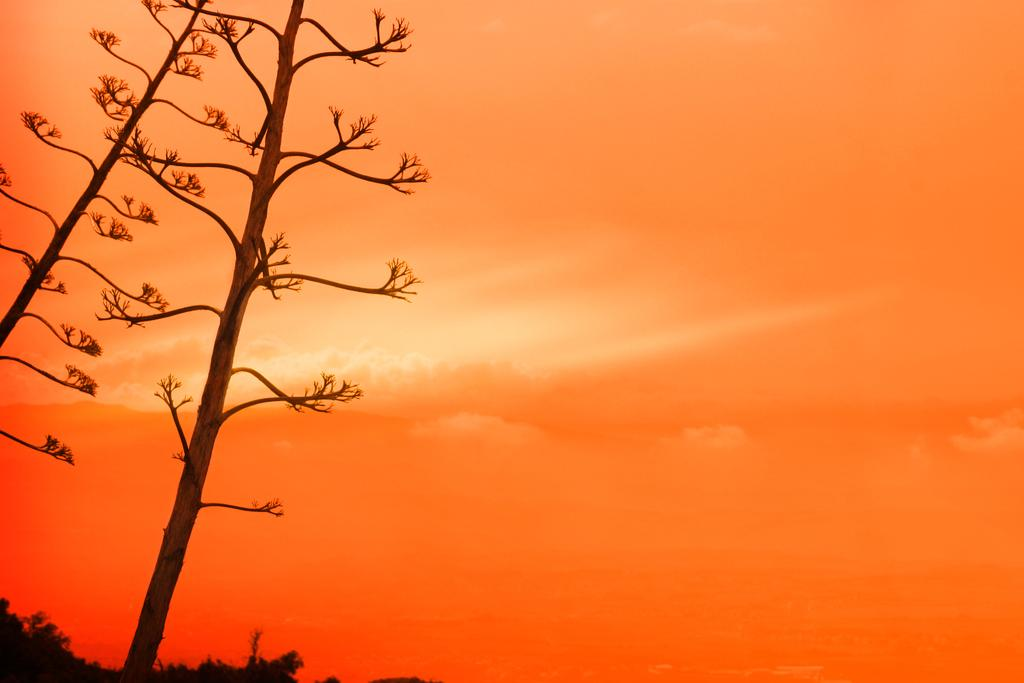What type of vegetation is on the left side of the image? There are trees on the left side of the image. What can be seen in the middle of the image? There are clouds in the middle of the image. What else is visible in the middle of the image besides the clouds? The sky is also visible in the middle of the image. What type of toy is being used at the party in the image? There is no toy or party present in the image; it features trees, clouds, and the sky. Who is the representative of the group in the image? There is no group or representative present in the image. 